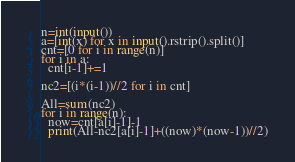<code> <loc_0><loc_0><loc_500><loc_500><_Python_>n=int(input())
a=[int(x) for x in input().rstrip().split()]
cnt=[0 for i in range(n)]
for i in a:
  cnt[i-1]+=1

nc2=[(i*(i-1))//2 for i in cnt]

All=sum(nc2)
for i in range(n):
  now=cnt[a[i]-1]-1
  print(All-nc2[a[i]-1]+((now)*(now-1))//2)
</code> 